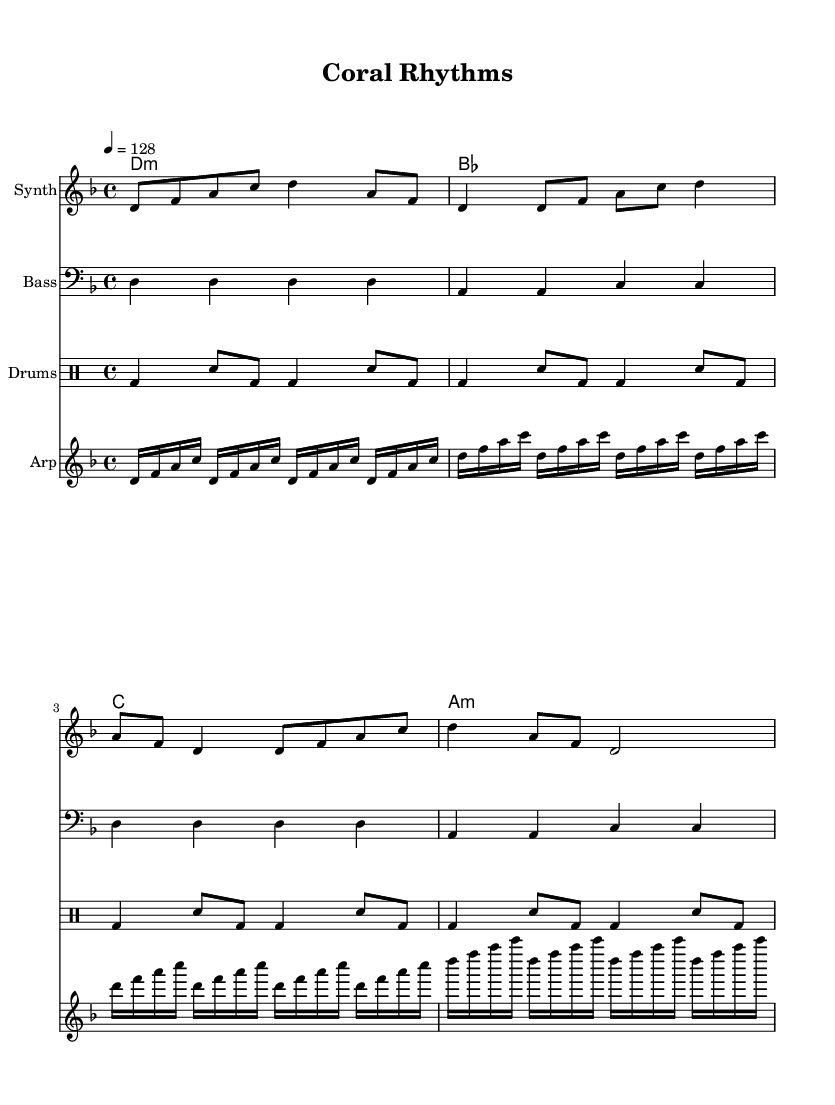what is the key signature of this music? The key signature is determined by looking at the key signature section in the global block. The music is in D minor, which is indicated by one flat in the key signature.
Answer: D minor what is the time signature of this music? The time signature can be found in the global block where it indicates 4/4, meaning there are four beats in each measure and the quarter note gets one beat.
Answer: 4/4 what is the tempo marking of this piece? The tempo is indicated in the global block where it specifies 4 = 128, meaning the quarter note should be played at a speed of 128 beats per minute.
Answer: 128 how many measures are in the synth part? To find the number of measures, count the divisions in the synth staff. There are 8 measures in total when counting the bars.
Answer: 8 what is the chord progression used in the piece? The chord progression can be found in the chordNames section. It follows the pattern of D minor, B flat, C, and A minor for each measure.
Answer: D minor, B flat, C, A minor what type of synthesizer sound is represented in this music? The synthesizer part is indicated as "Synth" in the staff heading and typically represents electronic sounds, which suggests an electronic dance music style.
Answer: Synth how is the rhythm structured in the drum part? The drum part shows a consistent pattern of bass drums and snare hits. Each measure contains a repeated rhythmic structure with a bass followed by a snare, creating a driving beat often found in dance music.
Answer: Driving beat 